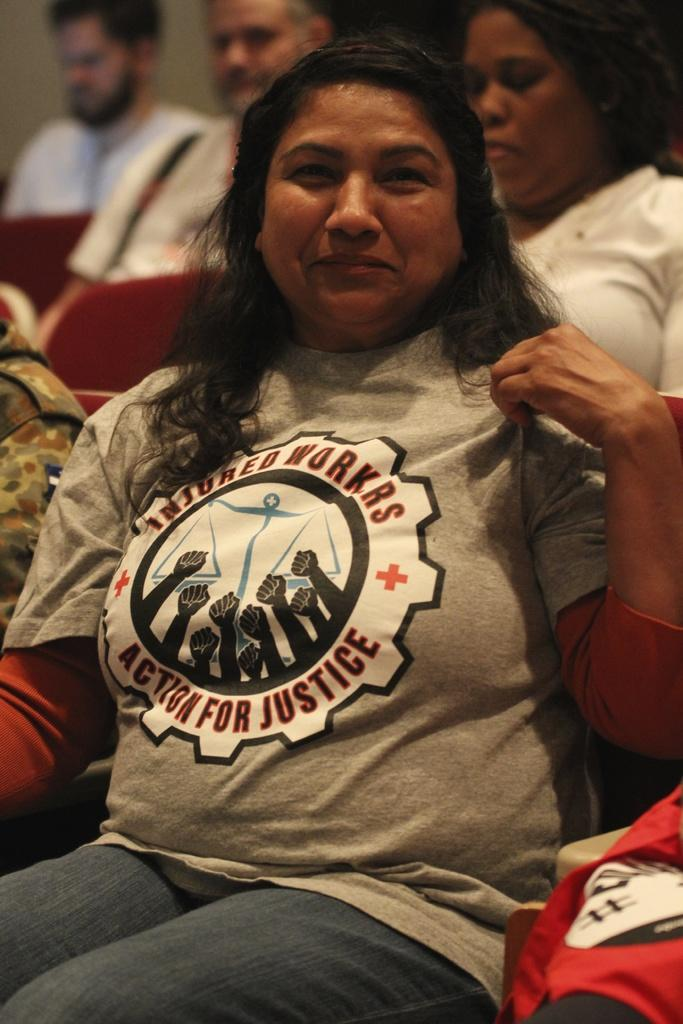<image>
Write a terse but informative summary of the picture. A hispanic woman is sitting and wears a shirt that says "Insured Workers, Action for Justice". 